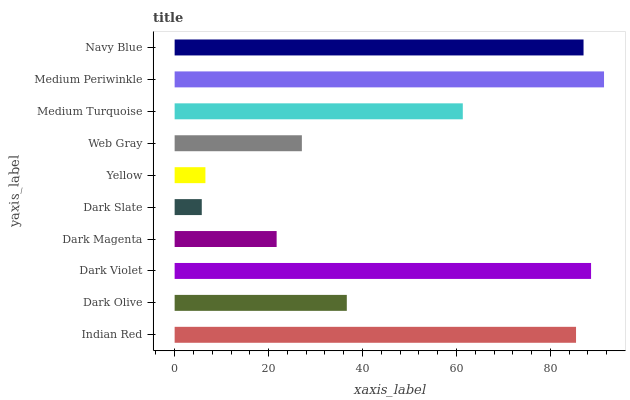Is Dark Slate the minimum?
Answer yes or no. Yes. Is Medium Periwinkle the maximum?
Answer yes or no. Yes. Is Dark Olive the minimum?
Answer yes or no. No. Is Dark Olive the maximum?
Answer yes or no. No. Is Indian Red greater than Dark Olive?
Answer yes or no. Yes. Is Dark Olive less than Indian Red?
Answer yes or no. Yes. Is Dark Olive greater than Indian Red?
Answer yes or no. No. Is Indian Red less than Dark Olive?
Answer yes or no. No. Is Medium Turquoise the high median?
Answer yes or no. Yes. Is Dark Olive the low median?
Answer yes or no. Yes. Is Dark Magenta the high median?
Answer yes or no. No. Is Web Gray the low median?
Answer yes or no. No. 